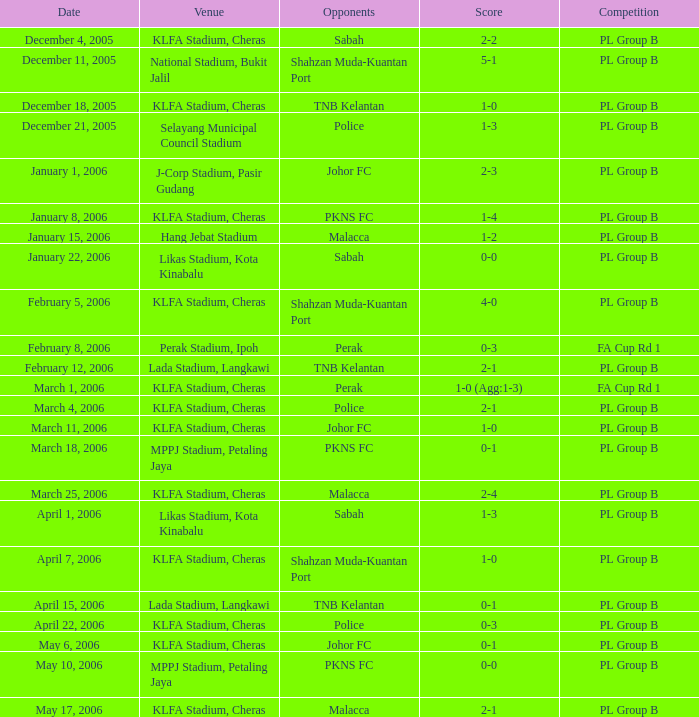Who were the competitors on may 6th, 2006? Johor FC. 